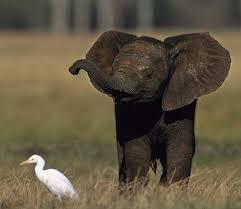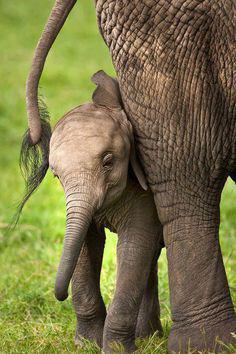The first image is the image on the left, the second image is the image on the right. For the images shown, is this caption "A small white bird with a long beak appears in one image standing near at least one elephant." true? Answer yes or no. Yes. The first image is the image on the left, the second image is the image on the right. Assess this claim about the two images: "An image shows at least one elephant with feet in the water.". Correct or not? Answer yes or no. No. 